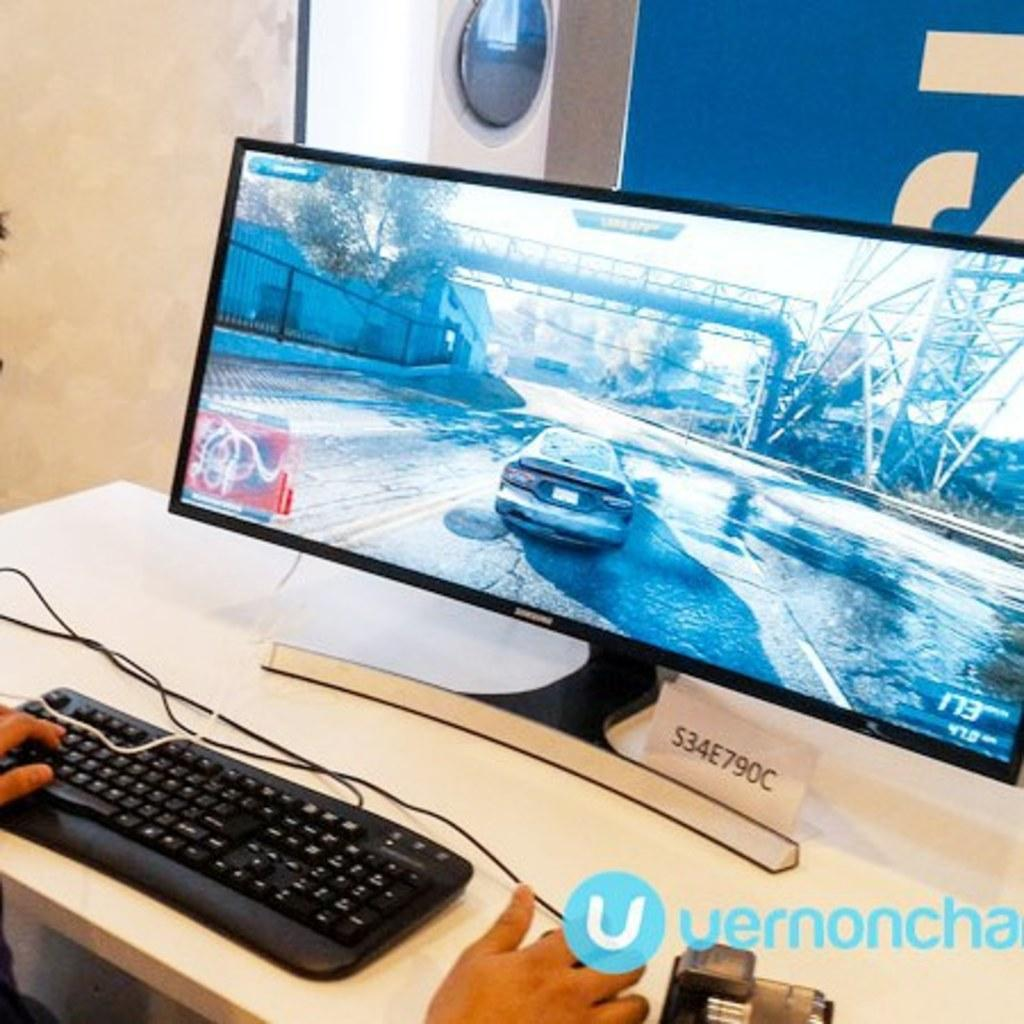What is the main subject of the image? The main subject of the image is a system. What can be seen on the table in the image? There are persons' hands on the table in the image. What is visible on the wall in the background of the image? There is a board on the wall in the background of the image. How many rabbits are jumping on the system in the image? There are no rabbits present in the image, so it is not possible to determine how many would be jumping on the system. 